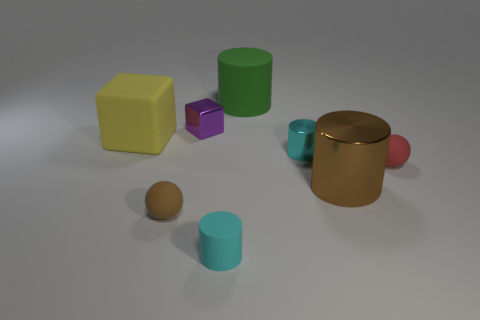How many objects are there, and can you describe them? There are seven objects in the image: a yellow matte block, a purple cube, a green cylinder, a golden cylinder with a metallic sheen, a teal cylinder, a brown sphere, and a red sphere with a glossy finish, each with its own unique color and texture, creating a visually engaging composition. 